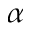Convert formula to latex. <formula><loc_0><loc_0><loc_500><loc_500>\alpha</formula> 